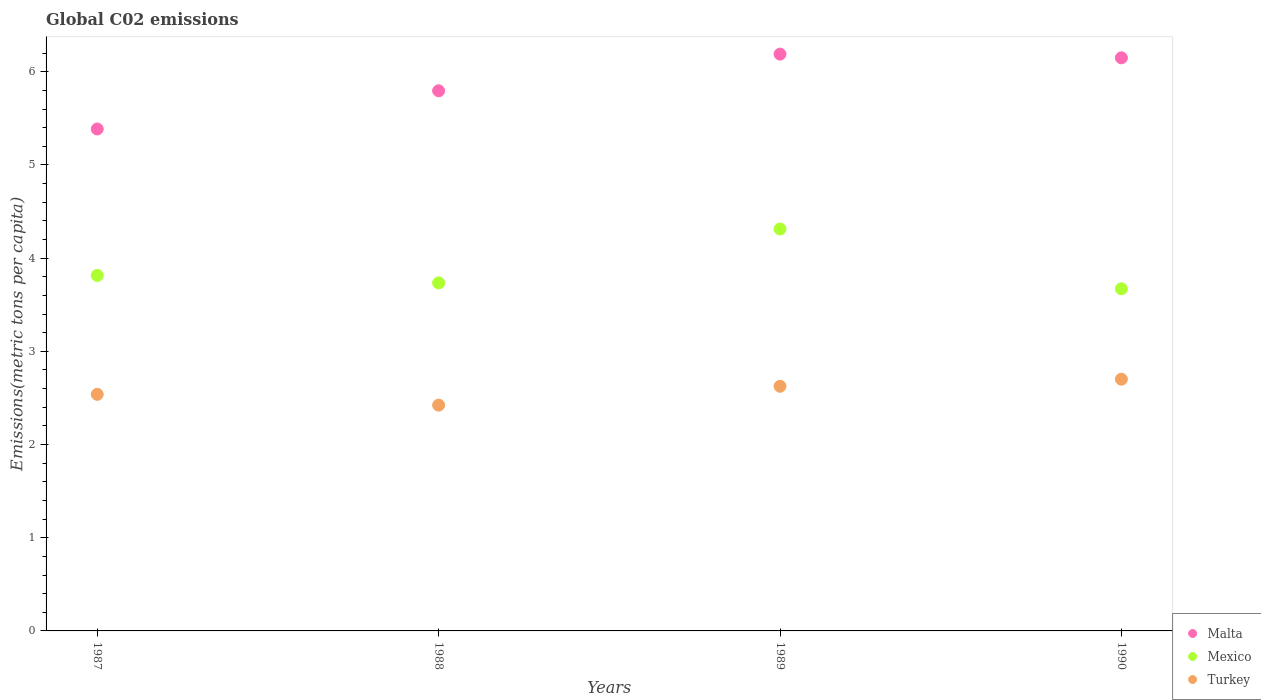How many different coloured dotlines are there?
Provide a short and direct response. 3. Is the number of dotlines equal to the number of legend labels?
Make the answer very short. Yes. What is the amount of CO2 emitted in in Mexico in 1989?
Provide a short and direct response. 4.31. Across all years, what is the maximum amount of CO2 emitted in in Mexico?
Provide a short and direct response. 4.31. Across all years, what is the minimum amount of CO2 emitted in in Mexico?
Your response must be concise. 3.67. In which year was the amount of CO2 emitted in in Mexico maximum?
Make the answer very short. 1989. What is the total amount of CO2 emitted in in Turkey in the graph?
Ensure brevity in your answer.  10.29. What is the difference between the amount of CO2 emitted in in Malta in 1987 and that in 1988?
Make the answer very short. -0.41. What is the difference between the amount of CO2 emitted in in Malta in 1988 and the amount of CO2 emitted in in Turkey in 1987?
Offer a terse response. 3.26. What is the average amount of CO2 emitted in in Malta per year?
Give a very brief answer. 5.88. In the year 1987, what is the difference between the amount of CO2 emitted in in Malta and amount of CO2 emitted in in Mexico?
Keep it short and to the point. 1.57. What is the ratio of the amount of CO2 emitted in in Turkey in 1988 to that in 1990?
Your response must be concise. 0.9. Is the difference between the amount of CO2 emitted in in Malta in 1989 and 1990 greater than the difference between the amount of CO2 emitted in in Mexico in 1989 and 1990?
Your answer should be very brief. No. What is the difference between the highest and the second highest amount of CO2 emitted in in Malta?
Your response must be concise. 0.04. What is the difference between the highest and the lowest amount of CO2 emitted in in Turkey?
Your answer should be compact. 0.28. Is the sum of the amount of CO2 emitted in in Turkey in 1988 and 1989 greater than the maximum amount of CO2 emitted in in Malta across all years?
Ensure brevity in your answer.  No. Does the amount of CO2 emitted in in Mexico monotonically increase over the years?
Offer a terse response. No. Is the amount of CO2 emitted in in Mexico strictly greater than the amount of CO2 emitted in in Turkey over the years?
Ensure brevity in your answer.  Yes. Is the amount of CO2 emitted in in Turkey strictly less than the amount of CO2 emitted in in Mexico over the years?
Your answer should be very brief. Yes. How many years are there in the graph?
Your answer should be very brief. 4. What is the difference between two consecutive major ticks on the Y-axis?
Provide a succinct answer. 1. Does the graph contain any zero values?
Provide a succinct answer. No. How many legend labels are there?
Offer a very short reply. 3. How are the legend labels stacked?
Give a very brief answer. Vertical. What is the title of the graph?
Offer a terse response. Global C02 emissions. What is the label or title of the Y-axis?
Offer a terse response. Emissions(metric tons per capita). What is the Emissions(metric tons per capita) of Malta in 1987?
Offer a terse response. 5.39. What is the Emissions(metric tons per capita) in Mexico in 1987?
Make the answer very short. 3.81. What is the Emissions(metric tons per capita) in Turkey in 1987?
Give a very brief answer. 2.54. What is the Emissions(metric tons per capita) of Malta in 1988?
Your answer should be compact. 5.8. What is the Emissions(metric tons per capita) of Mexico in 1988?
Offer a very short reply. 3.73. What is the Emissions(metric tons per capita) of Turkey in 1988?
Keep it short and to the point. 2.42. What is the Emissions(metric tons per capita) in Malta in 1989?
Your answer should be very brief. 6.19. What is the Emissions(metric tons per capita) in Mexico in 1989?
Keep it short and to the point. 4.31. What is the Emissions(metric tons per capita) of Turkey in 1989?
Your response must be concise. 2.63. What is the Emissions(metric tons per capita) of Malta in 1990?
Provide a succinct answer. 6.15. What is the Emissions(metric tons per capita) in Mexico in 1990?
Keep it short and to the point. 3.67. What is the Emissions(metric tons per capita) of Turkey in 1990?
Provide a succinct answer. 2.7. Across all years, what is the maximum Emissions(metric tons per capita) of Malta?
Offer a very short reply. 6.19. Across all years, what is the maximum Emissions(metric tons per capita) in Mexico?
Provide a short and direct response. 4.31. Across all years, what is the maximum Emissions(metric tons per capita) in Turkey?
Provide a succinct answer. 2.7. Across all years, what is the minimum Emissions(metric tons per capita) of Malta?
Your answer should be very brief. 5.39. Across all years, what is the minimum Emissions(metric tons per capita) of Mexico?
Offer a very short reply. 3.67. Across all years, what is the minimum Emissions(metric tons per capita) of Turkey?
Make the answer very short. 2.42. What is the total Emissions(metric tons per capita) in Malta in the graph?
Offer a very short reply. 23.52. What is the total Emissions(metric tons per capita) of Mexico in the graph?
Give a very brief answer. 15.53. What is the total Emissions(metric tons per capita) of Turkey in the graph?
Give a very brief answer. 10.29. What is the difference between the Emissions(metric tons per capita) in Malta in 1987 and that in 1988?
Your answer should be very brief. -0.41. What is the difference between the Emissions(metric tons per capita) in Mexico in 1987 and that in 1988?
Your response must be concise. 0.08. What is the difference between the Emissions(metric tons per capita) in Turkey in 1987 and that in 1988?
Your answer should be very brief. 0.12. What is the difference between the Emissions(metric tons per capita) of Malta in 1987 and that in 1989?
Your answer should be very brief. -0.8. What is the difference between the Emissions(metric tons per capita) of Mexico in 1987 and that in 1989?
Offer a very short reply. -0.5. What is the difference between the Emissions(metric tons per capita) of Turkey in 1987 and that in 1989?
Your response must be concise. -0.09. What is the difference between the Emissions(metric tons per capita) of Malta in 1987 and that in 1990?
Offer a terse response. -0.76. What is the difference between the Emissions(metric tons per capita) in Mexico in 1987 and that in 1990?
Provide a succinct answer. 0.14. What is the difference between the Emissions(metric tons per capita) in Turkey in 1987 and that in 1990?
Give a very brief answer. -0.16. What is the difference between the Emissions(metric tons per capita) in Malta in 1988 and that in 1989?
Keep it short and to the point. -0.39. What is the difference between the Emissions(metric tons per capita) in Mexico in 1988 and that in 1989?
Offer a very short reply. -0.58. What is the difference between the Emissions(metric tons per capita) in Turkey in 1988 and that in 1989?
Your answer should be very brief. -0.2. What is the difference between the Emissions(metric tons per capita) of Malta in 1988 and that in 1990?
Offer a very short reply. -0.35. What is the difference between the Emissions(metric tons per capita) in Mexico in 1988 and that in 1990?
Provide a short and direct response. 0.06. What is the difference between the Emissions(metric tons per capita) in Turkey in 1988 and that in 1990?
Provide a short and direct response. -0.28. What is the difference between the Emissions(metric tons per capita) in Malta in 1989 and that in 1990?
Offer a terse response. 0.04. What is the difference between the Emissions(metric tons per capita) in Mexico in 1989 and that in 1990?
Offer a terse response. 0.64. What is the difference between the Emissions(metric tons per capita) of Turkey in 1989 and that in 1990?
Provide a succinct answer. -0.08. What is the difference between the Emissions(metric tons per capita) of Malta in 1987 and the Emissions(metric tons per capita) of Mexico in 1988?
Give a very brief answer. 1.65. What is the difference between the Emissions(metric tons per capita) in Malta in 1987 and the Emissions(metric tons per capita) in Turkey in 1988?
Give a very brief answer. 2.96. What is the difference between the Emissions(metric tons per capita) in Mexico in 1987 and the Emissions(metric tons per capita) in Turkey in 1988?
Give a very brief answer. 1.39. What is the difference between the Emissions(metric tons per capita) in Malta in 1987 and the Emissions(metric tons per capita) in Mexico in 1989?
Your answer should be compact. 1.07. What is the difference between the Emissions(metric tons per capita) in Malta in 1987 and the Emissions(metric tons per capita) in Turkey in 1989?
Keep it short and to the point. 2.76. What is the difference between the Emissions(metric tons per capita) in Mexico in 1987 and the Emissions(metric tons per capita) in Turkey in 1989?
Make the answer very short. 1.19. What is the difference between the Emissions(metric tons per capita) in Malta in 1987 and the Emissions(metric tons per capita) in Mexico in 1990?
Your response must be concise. 1.72. What is the difference between the Emissions(metric tons per capita) of Malta in 1987 and the Emissions(metric tons per capita) of Turkey in 1990?
Provide a succinct answer. 2.69. What is the difference between the Emissions(metric tons per capita) in Mexico in 1987 and the Emissions(metric tons per capita) in Turkey in 1990?
Give a very brief answer. 1.11. What is the difference between the Emissions(metric tons per capita) of Malta in 1988 and the Emissions(metric tons per capita) of Mexico in 1989?
Make the answer very short. 1.48. What is the difference between the Emissions(metric tons per capita) in Malta in 1988 and the Emissions(metric tons per capita) in Turkey in 1989?
Make the answer very short. 3.17. What is the difference between the Emissions(metric tons per capita) in Mexico in 1988 and the Emissions(metric tons per capita) in Turkey in 1989?
Make the answer very short. 1.11. What is the difference between the Emissions(metric tons per capita) in Malta in 1988 and the Emissions(metric tons per capita) in Mexico in 1990?
Your answer should be compact. 2.12. What is the difference between the Emissions(metric tons per capita) in Malta in 1988 and the Emissions(metric tons per capita) in Turkey in 1990?
Provide a short and direct response. 3.09. What is the difference between the Emissions(metric tons per capita) in Mexico in 1988 and the Emissions(metric tons per capita) in Turkey in 1990?
Give a very brief answer. 1.03. What is the difference between the Emissions(metric tons per capita) of Malta in 1989 and the Emissions(metric tons per capita) of Mexico in 1990?
Your response must be concise. 2.52. What is the difference between the Emissions(metric tons per capita) of Malta in 1989 and the Emissions(metric tons per capita) of Turkey in 1990?
Provide a short and direct response. 3.49. What is the difference between the Emissions(metric tons per capita) in Mexico in 1989 and the Emissions(metric tons per capita) in Turkey in 1990?
Your answer should be very brief. 1.61. What is the average Emissions(metric tons per capita) in Malta per year?
Give a very brief answer. 5.88. What is the average Emissions(metric tons per capita) in Mexico per year?
Your answer should be compact. 3.88. What is the average Emissions(metric tons per capita) in Turkey per year?
Your answer should be compact. 2.57. In the year 1987, what is the difference between the Emissions(metric tons per capita) in Malta and Emissions(metric tons per capita) in Mexico?
Ensure brevity in your answer.  1.57. In the year 1987, what is the difference between the Emissions(metric tons per capita) of Malta and Emissions(metric tons per capita) of Turkey?
Ensure brevity in your answer.  2.85. In the year 1987, what is the difference between the Emissions(metric tons per capita) in Mexico and Emissions(metric tons per capita) in Turkey?
Your answer should be compact. 1.28. In the year 1988, what is the difference between the Emissions(metric tons per capita) of Malta and Emissions(metric tons per capita) of Mexico?
Make the answer very short. 2.06. In the year 1988, what is the difference between the Emissions(metric tons per capita) in Malta and Emissions(metric tons per capita) in Turkey?
Provide a succinct answer. 3.37. In the year 1988, what is the difference between the Emissions(metric tons per capita) of Mexico and Emissions(metric tons per capita) of Turkey?
Provide a short and direct response. 1.31. In the year 1989, what is the difference between the Emissions(metric tons per capita) of Malta and Emissions(metric tons per capita) of Mexico?
Give a very brief answer. 1.88. In the year 1989, what is the difference between the Emissions(metric tons per capita) in Malta and Emissions(metric tons per capita) in Turkey?
Give a very brief answer. 3.56. In the year 1989, what is the difference between the Emissions(metric tons per capita) in Mexico and Emissions(metric tons per capita) in Turkey?
Provide a succinct answer. 1.69. In the year 1990, what is the difference between the Emissions(metric tons per capita) in Malta and Emissions(metric tons per capita) in Mexico?
Provide a succinct answer. 2.48. In the year 1990, what is the difference between the Emissions(metric tons per capita) in Malta and Emissions(metric tons per capita) in Turkey?
Your answer should be compact. 3.45. In the year 1990, what is the difference between the Emissions(metric tons per capita) of Mexico and Emissions(metric tons per capita) of Turkey?
Your answer should be compact. 0.97. What is the ratio of the Emissions(metric tons per capita) in Malta in 1987 to that in 1988?
Ensure brevity in your answer.  0.93. What is the ratio of the Emissions(metric tons per capita) in Mexico in 1987 to that in 1988?
Keep it short and to the point. 1.02. What is the ratio of the Emissions(metric tons per capita) in Turkey in 1987 to that in 1988?
Your answer should be compact. 1.05. What is the ratio of the Emissions(metric tons per capita) in Malta in 1987 to that in 1989?
Offer a terse response. 0.87. What is the ratio of the Emissions(metric tons per capita) in Mexico in 1987 to that in 1989?
Make the answer very short. 0.88. What is the ratio of the Emissions(metric tons per capita) of Malta in 1987 to that in 1990?
Provide a short and direct response. 0.88. What is the ratio of the Emissions(metric tons per capita) of Mexico in 1987 to that in 1990?
Keep it short and to the point. 1.04. What is the ratio of the Emissions(metric tons per capita) in Turkey in 1987 to that in 1990?
Offer a terse response. 0.94. What is the ratio of the Emissions(metric tons per capita) in Malta in 1988 to that in 1989?
Provide a short and direct response. 0.94. What is the ratio of the Emissions(metric tons per capita) of Mexico in 1988 to that in 1989?
Your response must be concise. 0.87. What is the ratio of the Emissions(metric tons per capita) in Turkey in 1988 to that in 1989?
Give a very brief answer. 0.92. What is the ratio of the Emissions(metric tons per capita) in Malta in 1988 to that in 1990?
Make the answer very short. 0.94. What is the ratio of the Emissions(metric tons per capita) in Mexico in 1988 to that in 1990?
Offer a terse response. 1.02. What is the ratio of the Emissions(metric tons per capita) in Turkey in 1988 to that in 1990?
Provide a succinct answer. 0.9. What is the ratio of the Emissions(metric tons per capita) of Malta in 1989 to that in 1990?
Your answer should be compact. 1.01. What is the ratio of the Emissions(metric tons per capita) of Mexico in 1989 to that in 1990?
Offer a very short reply. 1.17. What is the ratio of the Emissions(metric tons per capita) of Turkey in 1989 to that in 1990?
Offer a very short reply. 0.97. What is the difference between the highest and the second highest Emissions(metric tons per capita) in Malta?
Provide a short and direct response. 0.04. What is the difference between the highest and the second highest Emissions(metric tons per capita) of Mexico?
Offer a very short reply. 0.5. What is the difference between the highest and the second highest Emissions(metric tons per capita) of Turkey?
Your response must be concise. 0.08. What is the difference between the highest and the lowest Emissions(metric tons per capita) in Malta?
Your answer should be very brief. 0.8. What is the difference between the highest and the lowest Emissions(metric tons per capita) of Mexico?
Make the answer very short. 0.64. What is the difference between the highest and the lowest Emissions(metric tons per capita) in Turkey?
Provide a short and direct response. 0.28. 